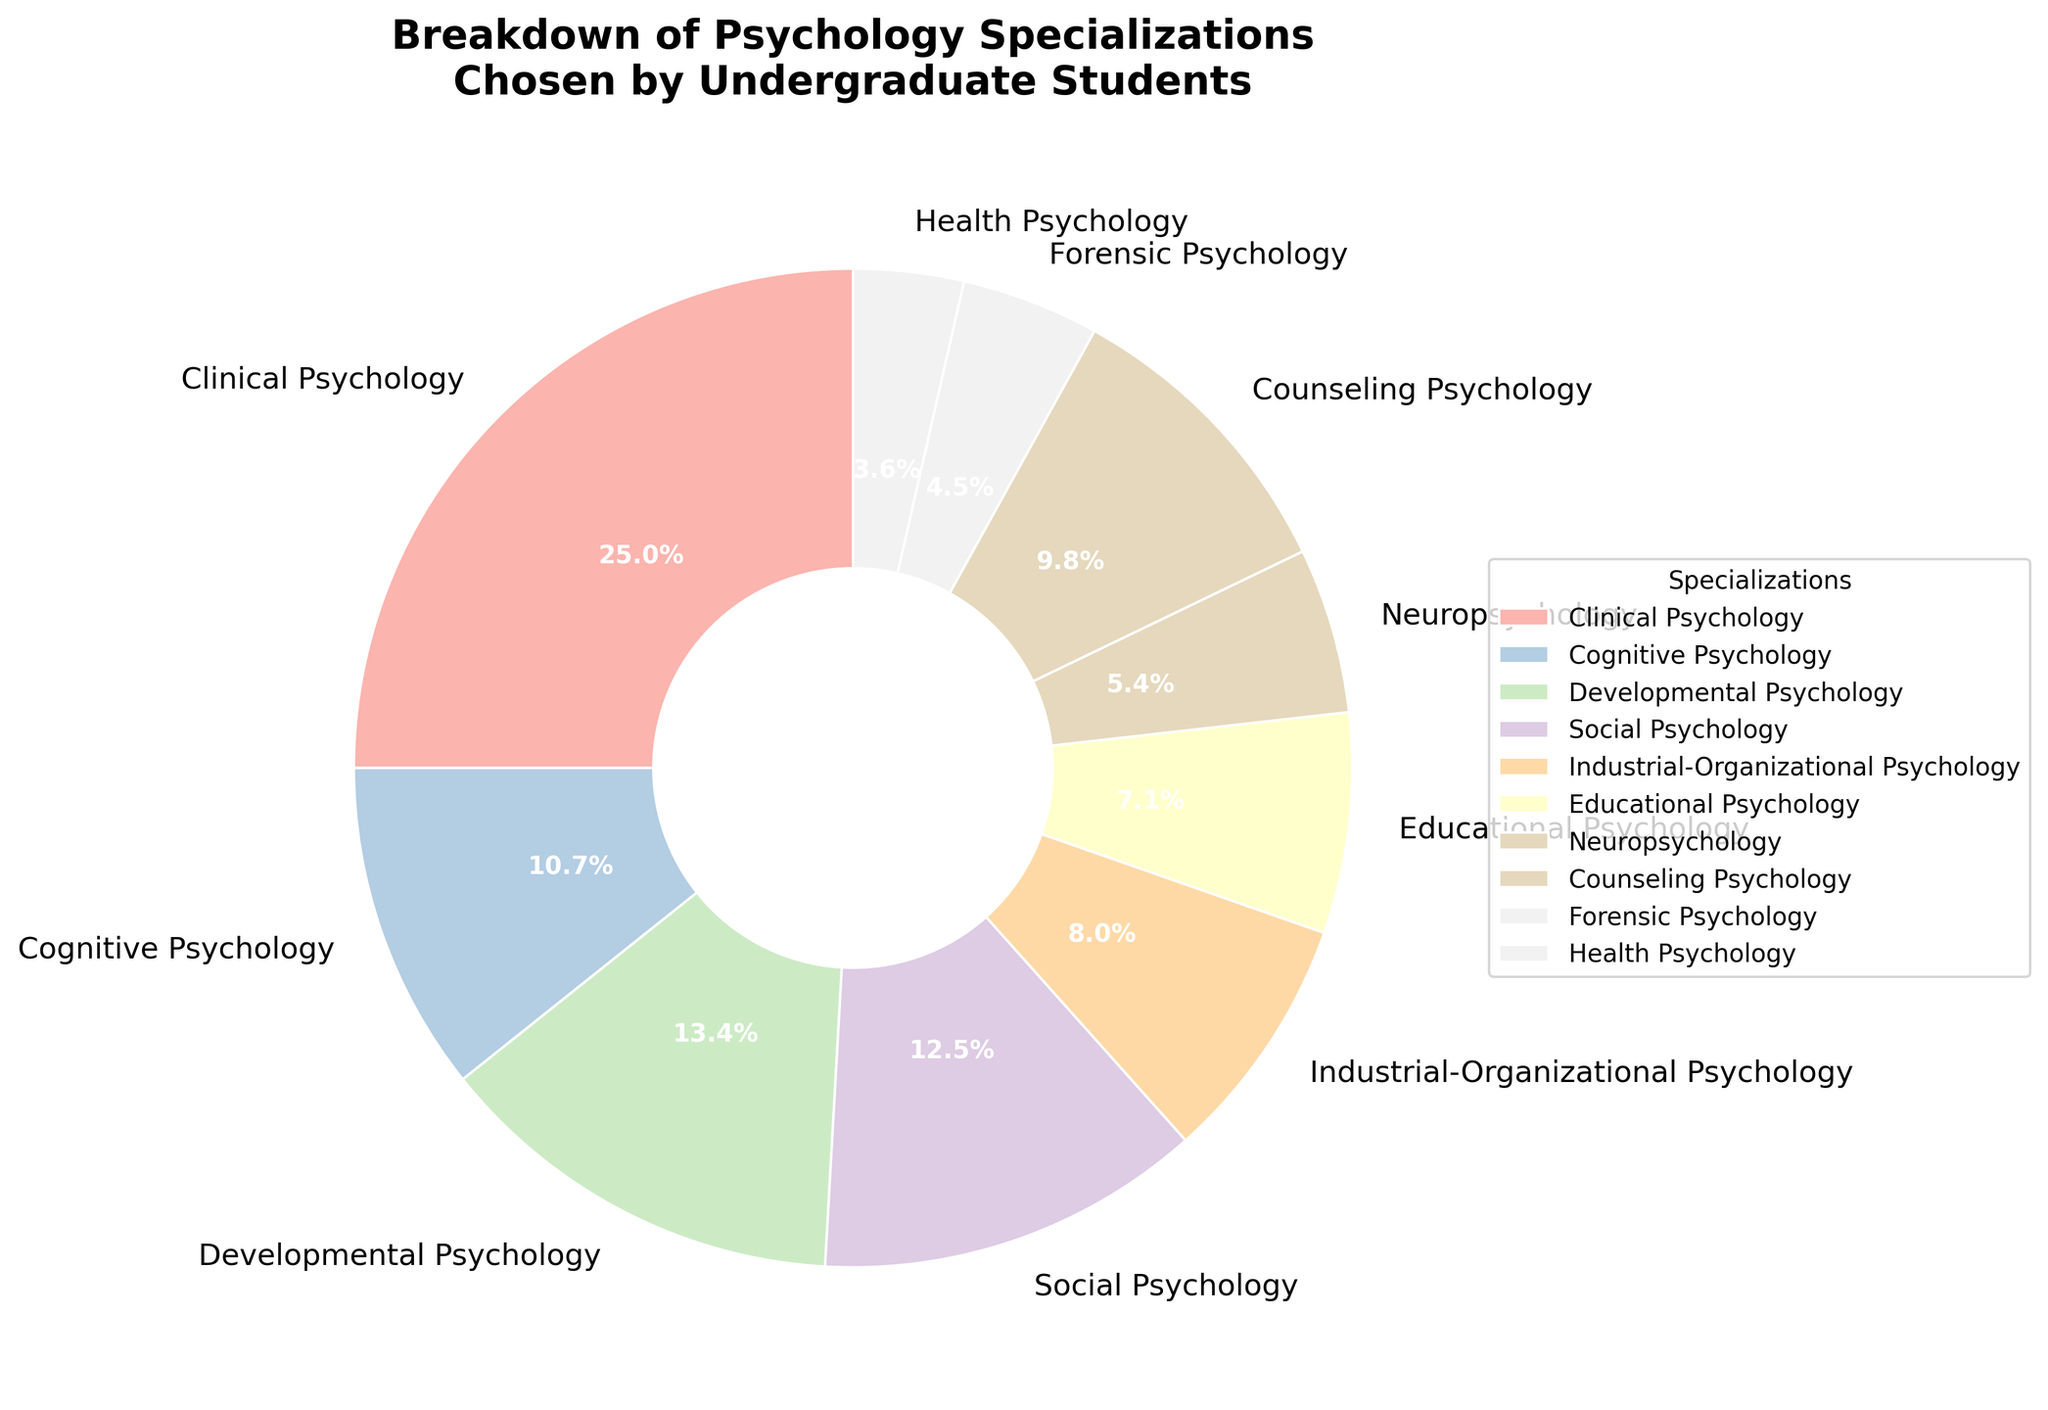What's the percentage of students choosing Clinical Psychology? Clinical Psychology is one of the specializations listed in the pie chart. By referring to the figure, it shows that Clinical Psychology accounts for 28% of the total.
Answer: 28% Which specialization has the lowest percentage of students choosing it? To find the specialization with the lowest percentage, we look for the smallest segment in the pie chart. Forensic Psychology has the smallest segment, representing 5% on the chart.
Answer: Forensic Psychology What is the combined percentage of students choosing Cognitive Psychology and Neuropsychology? The percentages for Cognitive Psychology and Neuropsychology are 12% and 6%, respectively. Adding these two together gives 12% + 6% = 18%.
Answer: 18% How does the percentage of students choosing Developmental Psychology compare to those choosing Counseling Psychology? Developmental Psychology represents 15% and Counseling Psychology represents 11% on the pie chart. Therefore, more students chose Developmental Psychology than Counseling Psychology.
Answer: More students chose Developmental Psychology What is the percentage gap between students choosing Social Psychology and those choosing Industrial-Organizational Psychology? Social Psychology accounts for 14% and Industrial-Organizational Psychology accounts for 9%. The gap between them is 14% - 9% = 5%.
Answer: 5% What percentage of students chose specializations other than Clinical Psychology? Clinical Psychology represents 28% of the total. Therefore, the percentage of students choosing other specializations is 100% - 28% = 72%.
Answer: 72% Which specialization has the second-highest percentage of students choosing it? The highest percentage is Clinical Psychology with 28%. The next highest percentage is Developmental Psychology with 15%.
Answer: Developmental Psychology Are there more students choosing Health Psychology or Educational Psychology? On the pie chart, Health Psychology represents 4% while Educational Psychology represents 8%. Therefore, more students chose Educational Psychology.
Answer: Educational Psychology What's the total percentage of students who chose Forensic Psychology, Health Psychology, and Neuropsychology combined? Adding the percentages of Forensic Psychology (5%), Health Psychology (4%), and Neuropsychology (6%) gives us 5% + 4% + 6% = 15%.
Answer: 15% Compare the combined percentage of Clinical and Counseling Psychology to Social and Industrial-Organizational Psychology. Which is higher? Clinical and Counseling Psychology combined is 28% + 11% = 39%. Social and Industrial-Organizational Psychology combined is 14% + 9% = 23%. Therefore, Clinical and Counseling Psychology have a higher combined percentage.
Answer: Clinical and Counseling Psychology 